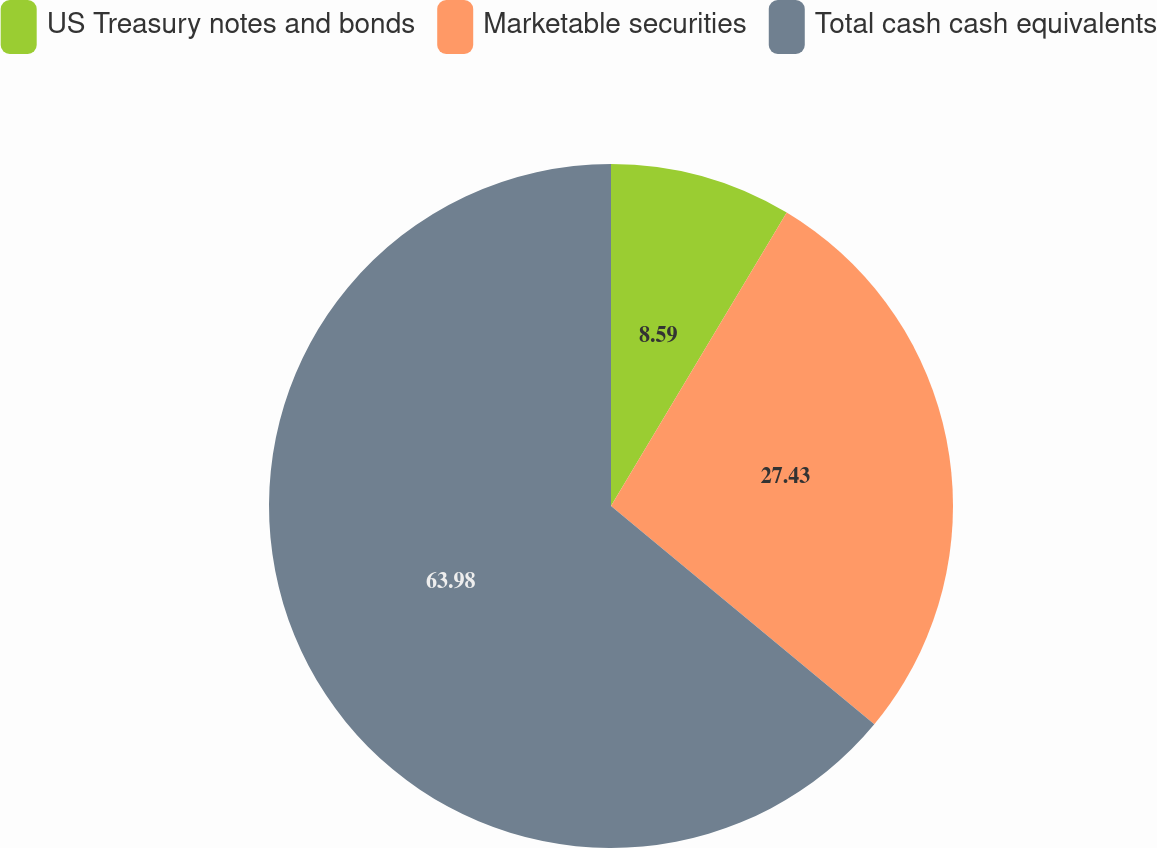Convert chart. <chart><loc_0><loc_0><loc_500><loc_500><pie_chart><fcel>US Treasury notes and bonds<fcel>Marketable securities<fcel>Total cash cash equivalents<nl><fcel>8.59%<fcel>27.43%<fcel>63.99%<nl></chart> 